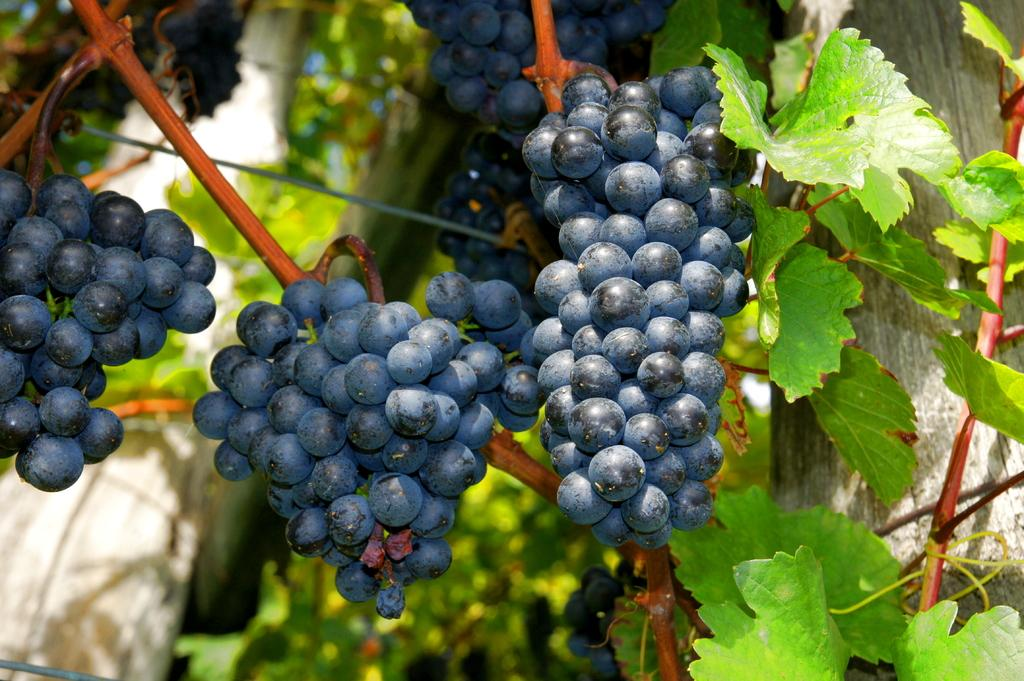What is the main subject of the zoomed-in picture? The main subject of the picture is a grape tree. Can you describe the level of detail in the image? The image is a zoomed-in picture, which means it provides a close-up view of the grape tree. What type of jelly can be seen hanging from the branches of the grape tree in the image? There is no jelly present on the grape tree in the image. How many wrists are visible in the image? There are no wrists visible in the image, as it features a grape tree. What type of glue is being used to attach the grapes to the tree in the image? There is no glue present in the image, as grapes naturally grow on trees. 